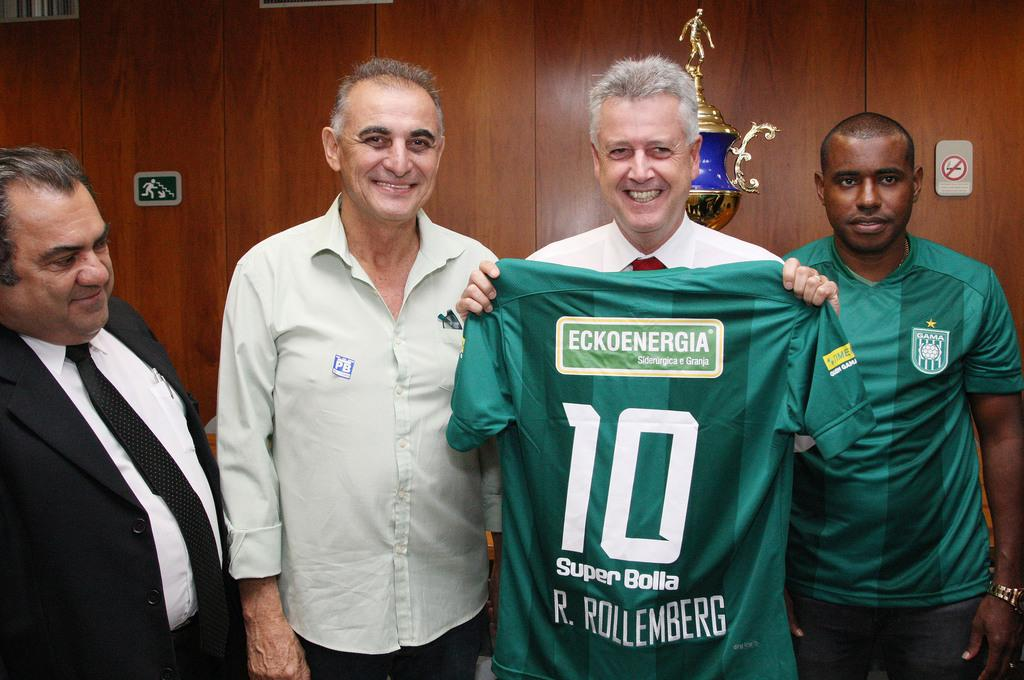<image>
Offer a succinct explanation of the picture presented. a man standing next to another one holding a jersey with the number 10 on it 